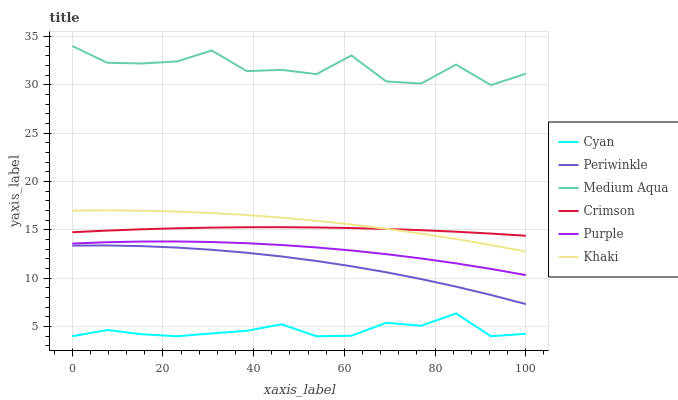Does Cyan have the minimum area under the curve?
Answer yes or no. Yes. Does Medium Aqua have the maximum area under the curve?
Answer yes or no. Yes. Does Purple have the minimum area under the curve?
Answer yes or no. No. Does Purple have the maximum area under the curve?
Answer yes or no. No. Is Crimson the smoothest?
Answer yes or no. Yes. Is Medium Aqua the roughest?
Answer yes or no. Yes. Is Purple the smoothest?
Answer yes or no. No. Is Purple the roughest?
Answer yes or no. No. Does Cyan have the lowest value?
Answer yes or no. Yes. Does Purple have the lowest value?
Answer yes or no. No. Does Medium Aqua have the highest value?
Answer yes or no. Yes. Does Purple have the highest value?
Answer yes or no. No. Is Periwinkle less than Purple?
Answer yes or no. Yes. Is Crimson greater than Purple?
Answer yes or no. Yes. Does Khaki intersect Crimson?
Answer yes or no. Yes. Is Khaki less than Crimson?
Answer yes or no. No. Is Khaki greater than Crimson?
Answer yes or no. No. Does Periwinkle intersect Purple?
Answer yes or no. No. 